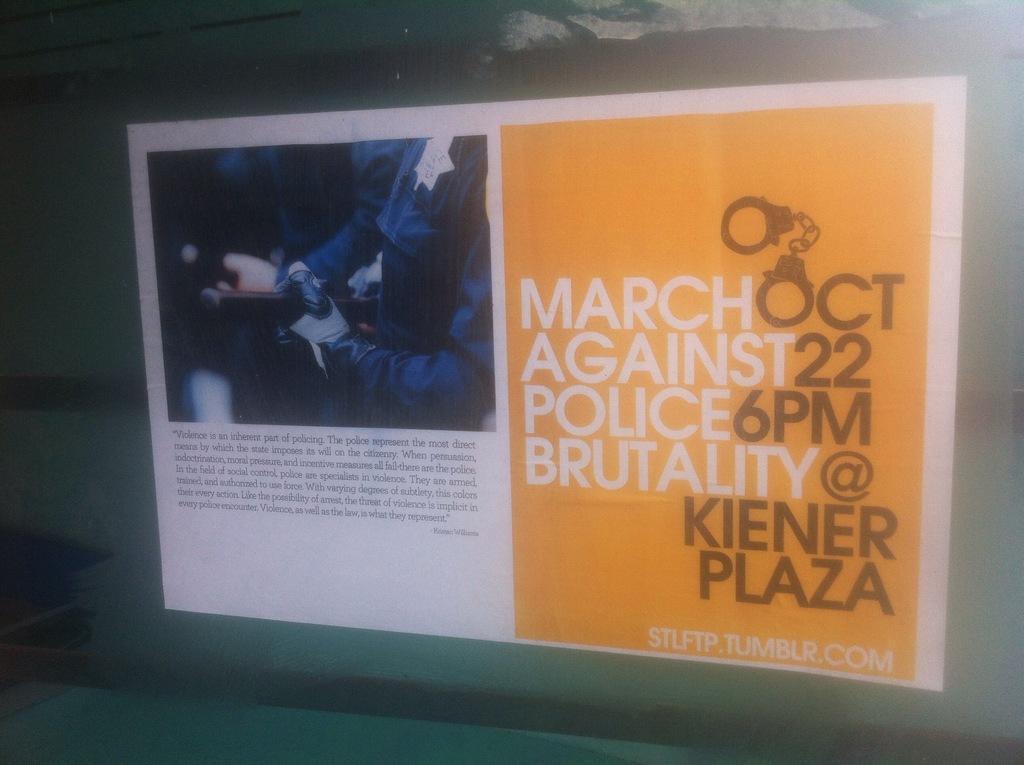Please provide a concise description of this image. This seems like projector screen on the wall and there is some text and picture of person in the screen. 